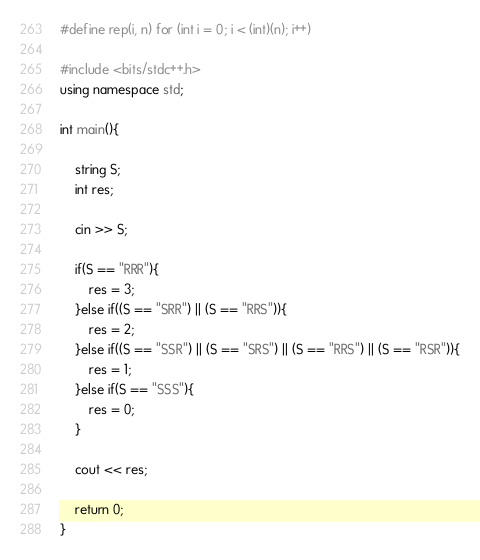<code> <loc_0><loc_0><loc_500><loc_500><_C++_>#define rep(i, n) for (int i = 0; i < (int)(n); i++)
 
#include <bits/stdc++.h>
using namespace std;

int main(){
	
	string S;
	int res;
	
	cin >> S;

	if(S == "RRR"){
		res = 3;
	}else if((S == "SRR") || (S == "RRS")){
		res = 2;
	}else if((S == "SSR") || (S == "SRS") || (S == "RRS") || (S == "RSR")){
		res = 1;
	}else if(S == "SSS"){
		res = 0;
	}

	cout << res;

	return 0;
}</code> 